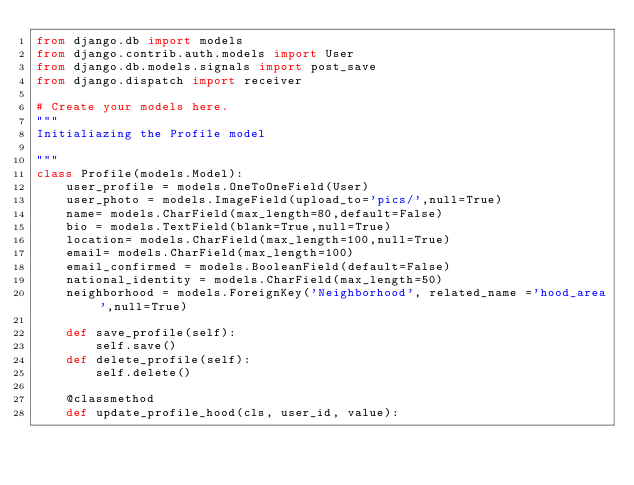<code> <loc_0><loc_0><loc_500><loc_500><_Python_>from django.db import models
from django.contrib.auth.models import User
from django.db.models.signals import post_save
from django.dispatch import receiver

# Create your models here.
"""
Initialiazing the Profile model

"""
class Profile(models.Model):
    user_profile = models.OneToOneField(User)
    user_photo = models.ImageField(upload_to='pics/',null=True)
    name= models.CharField(max_length=80,default=False)
    bio = models.TextField(blank=True,null=True)
    location= models.CharField(max_length=100,null=True)
    email= models.CharField(max_length=100)
    email_confirmed = models.BooleanField(default=False)
    national_identity = models.CharField(max_length=50)
    neighborhood = models.ForeignKey('Neighborhood', related_name ='hood_area',null=True)

    def save_profile(self):
        self.save()
    def delete_profile(self):
        self.delete()

    @classmethod
    def update_profile_hood(cls, user_id, value):</code> 